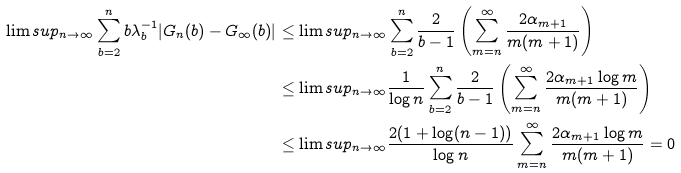Convert formula to latex. <formula><loc_0><loc_0><loc_500><loc_500>\lim s u p _ { n \rightarrow \infty } \sum _ { b = 2 } ^ { n } b \lambda _ { b } ^ { - 1 } | G _ { n } ( b ) - G _ { \infty } ( b ) | & \leq \lim s u p _ { n \rightarrow \infty } \sum _ { b = 2 } ^ { n } \frac { 2 } { b - 1 } \left ( \sum _ { m = n } ^ { \infty } \frac { 2 \alpha _ { m + 1 } } { m ( m + 1 ) } \right ) \\ & \leq \lim s u p _ { n \rightarrow \infty } \frac { 1 } { \log n } \sum _ { b = 2 } ^ { n } \frac { 2 } { b - 1 } \left ( \sum _ { m = n } ^ { \infty } \frac { 2 \alpha _ { m + 1 } \log m } { m ( m + 1 ) } \right ) \\ & \leq \lim s u p _ { n \rightarrow \infty } \frac { 2 ( 1 + \log ( n - 1 ) ) } { \log n } \sum _ { m = n } ^ { \infty } \frac { 2 \alpha _ { m + 1 } \log m } { m ( m + 1 ) } = 0</formula> 